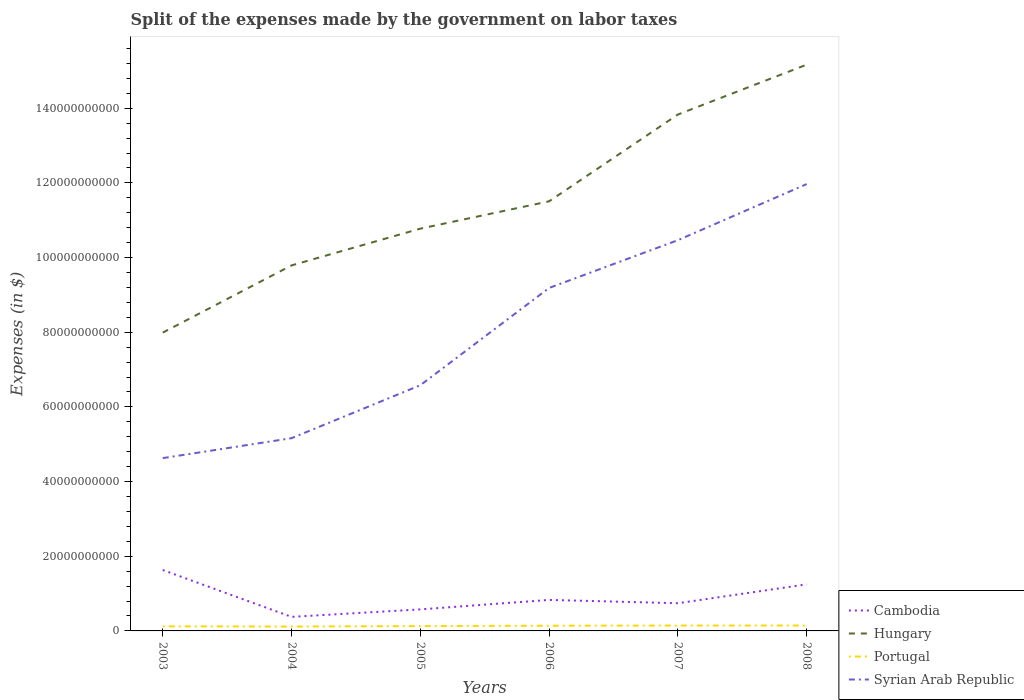Does the line corresponding to Cambodia intersect with the line corresponding to Syrian Arab Republic?
Provide a short and direct response. No. Across all years, what is the maximum expenses made by the government on labor taxes in Portugal?
Provide a succinct answer. 1.18e+09. What is the total expenses made by the government on labor taxes in Hungary in the graph?
Your response must be concise. -7.18e+1. What is the difference between the highest and the second highest expenses made by the government on labor taxes in Cambodia?
Offer a terse response. 1.26e+1. What is the difference between the highest and the lowest expenses made by the government on labor taxes in Hungary?
Keep it short and to the point. 2. Is the expenses made by the government on labor taxes in Hungary strictly greater than the expenses made by the government on labor taxes in Cambodia over the years?
Provide a short and direct response. No. How many years are there in the graph?
Ensure brevity in your answer.  6. Are the values on the major ticks of Y-axis written in scientific E-notation?
Your answer should be compact. No. Does the graph contain any zero values?
Make the answer very short. No. Does the graph contain grids?
Provide a short and direct response. No. How many legend labels are there?
Give a very brief answer. 4. How are the legend labels stacked?
Offer a terse response. Vertical. What is the title of the graph?
Offer a terse response. Split of the expenses made by the government on labor taxes. Does "Yemen, Rep." appear as one of the legend labels in the graph?
Give a very brief answer. No. What is the label or title of the X-axis?
Ensure brevity in your answer.  Years. What is the label or title of the Y-axis?
Make the answer very short. Expenses (in $). What is the Expenses (in $) of Cambodia in 2003?
Make the answer very short. 1.63e+1. What is the Expenses (in $) of Hungary in 2003?
Offer a very short reply. 7.99e+1. What is the Expenses (in $) in Portugal in 2003?
Your answer should be compact. 1.23e+09. What is the Expenses (in $) of Syrian Arab Republic in 2003?
Your response must be concise. 4.63e+1. What is the Expenses (in $) of Cambodia in 2004?
Give a very brief answer. 3.76e+09. What is the Expenses (in $) in Hungary in 2004?
Your answer should be compact. 9.79e+1. What is the Expenses (in $) of Portugal in 2004?
Ensure brevity in your answer.  1.18e+09. What is the Expenses (in $) in Syrian Arab Republic in 2004?
Provide a succinct answer. 5.16e+1. What is the Expenses (in $) of Cambodia in 2005?
Your response must be concise. 5.77e+09. What is the Expenses (in $) of Hungary in 2005?
Keep it short and to the point. 1.08e+11. What is the Expenses (in $) of Portugal in 2005?
Your response must be concise. 1.29e+09. What is the Expenses (in $) of Syrian Arab Republic in 2005?
Provide a short and direct response. 6.58e+1. What is the Expenses (in $) of Cambodia in 2006?
Your response must be concise. 8.30e+09. What is the Expenses (in $) in Hungary in 2006?
Your response must be concise. 1.15e+11. What is the Expenses (in $) of Portugal in 2006?
Make the answer very short. 1.39e+09. What is the Expenses (in $) in Syrian Arab Republic in 2006?
Ensure brevity in your answer.  9.19e+1. What is the Expenses (in $) of Cambodia in 2007?
Provide a succinct answer. 7.42e+09. What is the Expenses (in $) in Hungary in 2007?
Your answer should be compact. 1.38e+11. What is the Expenses (in $) of Portugal in 2007?
Your answer should be very brief. 1.44e+09. What is the Expenses (in $) in Syrian Arab Republic in 2007?
Your response must be concise. 1.05e+11. What is the Expenses (in $) in Cambodia in 2008?
Your answer should be very brief. 1.25e+1. What is the Expenses (in $) of Hungary in 2008?
Give a very brief answer. 1.52e+11. What is the Expenses (in $) of Portugal in 2008?
Your answer should be compact. 1.45e+09. What is the Expenses (in $) of Syrian Arab Republic in 2008?
Offer a very short reply. 1.20e+11. Across all years, what is the maximum Expenses (in $) in Cambodia?
Ensure brevity in your answer.  1.63e+1. Across all years, what is the maximum Expenses (in $) in Hungary?
Offer a terse response. 1.52e+11. Across all years, what is the maximum Expenses (in $) in Portugal?
Provide a short and direct response. 1.45e+09. Across all years, what is the maximum Expenses (in $) in Syrian Arab Republic?
Ensure brevity in your answer.  1.20e+11. Across all years, what is the minimum Expenses (in $) of Cambodia?
Your answer should be compact. 3.76e+09. Across all years, what is the minimum Expenses (in $) of Hungary?
Provide a succinct answer. 7.99e+1. Across all years, what is the minimum Expenses (in $) in Portugal?
Your response must be concise. 1.18e+09. Across all years, what is the minimum Expenses (in $) of Syrian Arab Republic?
Offer a very short reply. 4.63e+1. What is the total Expenses (in $) of Cambodia in the graph?
Make the answer very short. 5.40e+1. What is the total Expenses (in $) of Hungary in the graph?
Give a very brief answer. 6.91e+11. What is the total Expenses (in $) of Portugal in the graph?
Make the answer very short. 7.98e+09. What is the total Expenses (in $) in Syrian Arab Republic in the graph?
Ensure brevity in your answer.  4.80e+11. What is the difference between the Expenses (in $) in Cambodia in 2003 and that in 2004?
Give a very brief answer. 1.26e+1. What is the difference between the Expenses (in $) of Hungary in 2003 and that in 2004?
Make the answer very short. -1.80e+1. What is the difference between the Expenses (in $) of Portugal in 2003 and that in 2004?
Make the answer very short. 5.04e+07. What is the difference between the Expenses (in $) in Syrian Arab Republic in 2003 and that in 2004?
Offer a terse response. -5.34e+09. What is the difference between the Expenses (in $) of Cambodia in 2003 and that in 2005?
Offer a terse response. 1.05e+1. What is the difference between the Expenses (in $) of Hungary in 2003 and that in 2005?
Make the answer very short. -2.78e+1. What is the difference between the Expenses (in $) in Portugal in 2003 and that in 2005?
Offer a terse response. -6.48e+07. What is the difference between the Expenses (in $) in Syrian Arab Republic in 2003 and that in 2005?
Make the answer very short. -1.95e+1. What is the difference between the Expenses (in $) in Cambodia in 2003 and that in 2006?
Offer a very short reply. 8.01e+09. What is the difference between the Expenses (in $) in Hungary in 2003 and that in 2006?
Offer a terse response. -3.52e+1. What is the difference between the Expenses (in $) in Portugal in 2003 and that in 2006?
Provide a short and direct response. -1.65e+08. What is the difference between the Expenses (in $) of Syrian Arab Republic in 2003 and that in 2006?
Give a very brief answer. -4.56e+1. What is the difference between the Expenses (in $) of Cambodia in 2003 and that in 2007?
Your answer should be compact. 8.90e+09. What is the difference between the Expenses (in $) of Hungary in 2003 and that in 2007?
Your answer should be compact. -5.84e+1. What is the difference between the Expenses (in $) in Portugal in 2003 and that in 2007?
Offer a terse response. -2.08e+08. What is the difference between the Expenses (in $) in Syrian Arab Republic in 2003 and that in 2007?
Make the answer very short. -5.84e+1. What is the difference between the Expenses (in $) in Cambodia in 2003 and that in 2008?
Keep it short and to the point. 3.84e+09. What is the difference between the Expenses (in $) of Hungary in 2003 and that in 2008?
Provide a short and direct response. -7.18e+1. What is the difference between the Expenses (in $) of Portugal in 2003 and that in 2008?
Keep it short and to the point. -2.17e+08. What is the difference between the Expenses (in $) in Syrian Arab Republic in 2003 and that in 2008?
Give a very brief answer. -7.34e+1. What is the difference between the Expenses (in $) of Cambodia in 2004 and that in 2005?
Ensure brevity in your answer.  -2.01e+09. What is the difference between the Expenses (in $) in Hungary in 2004 and that in 2005?
Ensure brevity in your answer.  -9.84e+09. What is the difference between the Expenses (in $) in Portugal in 2004 and that in 2005?
Keep it short and to the point. -1.15e+08. What is the difference between the Expenses (in $) of Syrian Arab Republic in 2004 and that in 2005?
Provide a succinct answer. -1.42e+1. What is the difference between the Expenses (in $) in Cambodia in 2004 and that in 2006?
Offer a terse response. -4.54e+09. What is the difference between the Expenses (in $) of Hungary in 2004 and that in 2006?
Keep it short and to the point. -1.72e+1. What is the difference between the Expenses (in $) in Portugal in 2004 and that in 2006?
Offer a terse response. -2.15e+08. What is the difference between the Expenses (in $) in Syrian Arab Republic in 2004 and that in 2006?
Provide a short and direct response. -4.02e+1. What is the difference between the Expenses (in $) of Cambodia in 2004 and that in 2007?
Give a very brief answer. -3.66e+09. What is the difference between the Expenses (in $) in Hungary in 2004 and that in 2007?
Provide a succinct answer. -4.04e+1. What is the difference between the Expenses (in $) in Portugal in 2004 and that in 2007?
Give a very brief answer. -2.58e+08. What is the difference between the Expenses (in $) in Syrian Arab Republic in 2004 and that in 2007?
Your answer should be compact. -5.30e+1. What is the difference between the Expenses (in $) in Cambodia in 2004 and that in 2008?
Give a very brief answer. -8.72e+09. What is the difference between the Expenses (in $) in Hungary in 2004 and that in 2008?
Provide a succinct answer. -5.38e+1. What is the difference between the Expenses (in $) in Portugal in 2004 and that in 2008?
Your answer should be compact. -2.67e+08. What is the difference between the Expenses (in $) in Syrian Arab Republic in 2004 and that in 2008?
Provide a short and direct response. -6.81e+1. What is the difference between the Expenses (in $) in Cambodia in 2005 and that in 2006?
Your answer should be compact. -2.54e+09. What is the difference between the Expenses (in $) of Hungary in 2005 and that in 2006?
Provide a short and direct response. -7.32e+09. What is the difference between the Expenses (in $) in Portugal in 2005 and that in 2006?
Provide a succinct answer. -1.00e+08. What is the difference between the Expenses (in $) of Syrian Arab Republic in 2005 and that in 2006?
Provide a succinct answer. -2.61e+1. What is the difference between the Expenses (in $) of Cambodia in 2005 and that in 2007?
Make the answer very short. -1.65e+09. What is the difference between the Expenses (in $) in Hungary in 2005 and that in 2007?
Provide a short and direct response. -3.06e+1. What is the difference between the Expenses (in $) of Portugal in 2005 and that in 2007?
Your response must be concise. -1.43e+08. What is the difference between the Expenses (in $) in Syrian Arab Republic in 2005 and that in 2007?
Your answer should be compact. -3.89e+1. What is the difference between the Expenses (in $) of Cambodia in 2005 and that in 2008?
Your answer should be compact. -6.71e+09. What is the difference between the Expenses (in $) in Hungary in 2005 and that in 2008?
Offer a terse response. -4.39e+1. What is the difference between the Expenses (in $) of Portugal in 2005 and that in 2008?
Give a very brief answer. -1.52e+08. What is the difference between the Expenses (in $) of Syrian Arab Republic in 2005 and that in 2008?
Offer a very short reply. -5.39e+1. What is the difference between the Expenses (in $) in Cambodia in 2006 and that in 2007?
Your answer should be compact. 8.87e+08. What is the difference between the Expenses (in $) in Hungary in 2006 and that in 2007?
Your answer should be compact. -2.32e+1. What is the difference between the Expenses (in $) in Portugal in 2006 and that in 2007?
Your response must be concise. -4.29e+07. What is the difference between the Expenses (in $) of Syrian Arab Republic in 2006 and that in 2007?
Your answer should be very brief. -1.28e+1. What is the difference between the Expenses (in $) in Cambodia in 2006 and that in 2008?
Provide a short and direct response. -4.17e+09. What is the difference between the Expenses (in $) in Hungary in 2006 and that in 2008?
Ensure brevity in your answer.  -3.66e+1. What is the difference between the Expenses (in $) of Portugal in 2006 and that in 2008?
Give a very brief answer. -5.20e+07. What is the difference between the Expenses (in $) of Syrian Arab Republic in 2006 and that in 2008?
Make the answer very short. -2.78e+1. What is the difference between the Expenses (in $) in Cambodia in 2007 and that in 2008?
Offer a very short reply. -5.06e+09. What is the difference between the Expenses (in $) in Hungary in 2007 and that in 2008?
Provide a short and direct response. -1.34e+1. What is the difference between the Expenses (in $) of Portugal in 2007 and that in 2008?
Make the answer very short. -9.08e+06. What is the difference between the Expenses (in $) in Syrian Arab Republic in 2007 and that in 2008?
Give a very brief answer. -1.50e+1. What is the difference between the Expenses (in $) of Cambodia in 2003 and the Expenses (in $) of Hungary in 2004?
Your response must be concise. -8.16e+1. What is the difference between the Expenses (in $) in Cambodia in 2003 and the Expenses (in $) in Portugal in 2004?
Your answer should be very brief. 1.51e+1. What is the difference between the Expenses (in $) of Cambodia in 2003 and the Expenses (in $) of Syrian Arab Republic in 2004?
Keep it short and to the point. -3.53e+1. What is the difference between the Expenses (in $) of Hungary in 2003 and the Expenses (in $) of Portugal in 2004?
Ensure brevity in your answer.  7.87e+1. What is the difference between the Expenses (in $) in Hungary in 2003 and the Expenses (in $) in Syrian Arab Republic in 2004?
Provide a succinct answer. 2.83e+1. What is the difference between the Expenses (in $) in Portugal in 2003 and the Expenses (in $) in Syrian Arab Republic in 2004?
Offer a very short reply. -5.04e+1. What is the difference between the Expenses (in $) in Cambodia in 2003 and the Expenses (in $) in Hungary in 2005?
Offer a very short reply. -9.14e+1. What is the difference between the Expenses (in $) of Cambodia in 2003 and the Expenses (in $) of Portugal in 2005?
Offer a terse response. 1.50e+1. What is the difference between the Expenses (in $) in Cambodia in 2003 and the Expenses (in $) in Syrian Arab Republic in 2005?
Offer a terse response. -4.95e+1. What is the difference between the Expenses (in $) in Hungary in 2003 and the Expenses (in $) in Portugal in 2005?
Give a very brief answer. 7.86e+1. What is the difference between the Expenses (in $) in Hungary in 2003 and the Expenses (in $) in Syrian Arab Republic in 2005?
Your answer should be very brief. 1.41e+1. What is the difference between the Expenses (in $) in Portugal in 2003 and the Expenses (in $) in Syrian Arab Republic in 2005?
Offer a terse response. -6.46e+1. What is the difference between the Expenses (in $) of Cambodia in 2003 and the Expenses (in $) of Hungary in 2006?
Make the answer very short. -9.88e+1. What is the difference between the Expenses (in $) of Cambodia in 2003 and the Expenses (in $) of Portugal in 2006?
Ensure brevity in your answer.  1.49e+1. What is the difference between the Expenses (in $) in Cambodia in 2003 and the Expenses (in $) in Syrian Arab Republic in 2006?
Provide a short and direct response. -7.56e+1. What is the difference between the Expenses (in $) of Hungary in 2003 and the Expenses (in $) of Portugal in 2006?
Provide a succinct answer. 7.85e+1. What is the difference between the Expenses (in $) in Hungary in 2003 and the Expenses (in $) in Syrian Arab Republic in 2006?
Provide a short and direct response. -1.20e+1. What is the difference between the Expenses (in $) of Portugal in 2003 and the Expenses (in $) of Syrian Arab Republic in 2006?
Provide a succinct answer. -9.06e+1. What is the difference between the Expenses (in $) of Cambodia in 2003 and the Expenses (in $) of Hungary in 2007?
Make the answer very short. -1.22e+11. What is the difference between the Expenses (in $) in Cambodia in 2003 and the Expenses (in $) in Portugal in 2007?
Provide a short and direct response. 1.49e+1. What is the difference between the Expenses (in $) in Cambodia in 2003 and the Expenses (in $) in Syrian Arab Republic in 2007?
Provide a short and direct response. -8.83e+1. What is the difference between the Expenses (in $) of Hungary in 2003 and the Expenses (in $) of Portugal in 2007?
Make the answer very short. 7.85e+1. What is the difference between the Expenses (in $) of Hungary in 2003 and the Expenses (in $) of Syrian Arab Republic in 2007?
Provide a short and direct response. -2.48e+1. What is the difference between the Expenses (in $) of Portugal in 2003 and the Expenses (in $) of Syrian Arab Republic in 2007?
Offer a terse response. -1.03e+11. What is the difference between the Expenses (in $) of Cambodia in 2003 and the Expenses (in $) of Hungary in 2008?
Your answer should be very brief. -1.35e+11. What is the difference between the Expenses (in $) in Cambodia in 2003 and the Expenses (in $) in Portugal in 2008?
Keep it short and to the point. 1.49e+1. What is the difference between the Expenses (in $) of Cambodia in 2003 and the Expenses (in $) of Syrian Arab Republic in 2008?
Provide a short and direct response. -1.03e+11. What is the difference between the Expenses (in $) of Hungary in 2003 and the Expenses (in $) of Portugal in 2008?
Provide a short and direct response. 7.85e+1. What is the difference between the Expenses (in $) of Hungary in 2003 and the Expenses (in $) of Syrian Arab Republic in 2008?
Make the answer very short. -3.98e+1. What is the difference between the Expenses (in $) in Portugal in 2003 and the Expenses (in $) in Syrian Arab Republic in 2008?
Make the answer very short. -1.18e+11. What is the difference between the Expenses (in $) of Cambodia in 2004 and the Expenses (in $) of Hungary in 2005?
Make the answer very short. -1.04e+11. What is the difference between the Expenses (in $) of Cambodia in 2004 and the Expenses (in $) of Portugal in 2005?
Keep it short and to the point. 2.47e+09. What is the difference between the Expenses (in $) in Cambodia in 2004 and the Expenses (in $) in Syrian Arab Republic in 2005?
Offer a terse response. -6.20e+1. What is the difference between the Expenses (in $) in Hungary in 2004 and the Expenses (in $) in Portugal in 2005?
Keep it short and to the point. 9.66e+1. What is the difference between the Expenses (in $) in Hungary in 2004 and the Expenses (in $) in Syrian Arab Republic in 2005?
Provide a succinct answer. 3.21e+1. What is the difference between the Expenses (in $) in Portugal in 2004 and the Expenses (in $) in Syrian Arab Republic in 2005?
Your response must be concise. -6.46e+1. What is the difference between the Expenses (in $) in Cambodia in 2004 and the Expenses (in $) in Hungary in 2006?
Your response must be concise. -1.11e+11. What is the difference between the Expenses (in $) in Cambodia in 2004 and the Expenses (in $) in Portugal in 2006?
Keep it short and to the point. 2.37e+09. What is the difference between the Expenses (in $) in Cambodia in 2004 and the Expenses (in $) in Syrian Arab Republic in 2006?
Ensure brevity in your answer.  -8.81e+1. What is the difference between the Expenses (in $) in Hungary in 2004 and the Expenses (in $) in Portugal in 2006?
Give a very brief answer. 9.65e+1. What is the difference between the Expenses (in $) of Hungary in 2004 and the Expenses (in $) of Syrian Arab Republic in 2006?
Give a very brief answer. 6.04e+09. What is the difference between the Expenses (in $) of Portugal in 2004 and the Expenses (in $) of Syrian Arab Republic in 2006?
Offer a terse response. -9.07e+1. What is the difference between the Expenses (in $) of Cambodia in 2004 and the Expenses (in $) of Hungary in 2007?
Your response must be concise. -1.35e+11. What is the difference between the Expenses (in $) of Cambodia in 2004 and the Expenses (in $) of Portugal in 2007?
Keep it short and to the point. 2.33e+09. What is the difference between the Expenses (in $) in Cambodia in 2004 and the Expenses (in $) in Syrian Arab Republic in 2007?
Ensure brevity in your answer.  -1.01e+11. What is the difference between the Expenses (in $) of Hungary in 2004 and the Expenses (in $) of Portugal in 2007?
Ensure brevity in your answer.  9.65e+1. What is the difference between the Expenses (in $) of Hungary in 2004 and the Expenses (in $) of Syrian Arab Republic in 2007?
Provide a short and direct response. -6.76e+09. What is the difference between the Expenses (in $) of Portugal in 2004 and the Expenses (in $) of Syrian Arab Republic in 2007?
Your answer should be very brief. -1.03e+11. What is the difference between the Expenses (in $) in Cambodia in 2004 and the Expenses (in $) in Hungary in 2008?
Provide a short and direct response. -1.48e+11. What is the difference between the Expenses (in $) in Cambodia in 2004 and the Expenses (in $) in Portugal in 2008?
Your response must be concise. 2.32e+09. What is the difference between the Expenses (in $) of Cambodia in 2004 and the Expenses (in $) of Syrian Arab Republic in 2008?
Keep it short and to the point. -1.16e+11. What is the difference between the Expenses (in $) of Hungary in 2004 and the Expenses (in $) of Portugal in 2008?
Your answer should be compact. 9.65e+1. What is the difference between the Expenses (in $) in Hungary in 2004 and the Expenses (in $) in Syrian Arab Republic in 2008?
Give a very brief answer. -2.18e+1. What is the difference between the Expenses (in $) of Portugal in 2004 and the Expenses (in $) of Syrian Arab Republic in 2008?
Provide a succinct answer. -1.19e+11. What is the difference between the Expenses (in $) of Cambodia in 2005 and the Expenses (in $) of Hungary in 2006?
Your response must be concise. -1.09e+11. What is the difference between the Expenses (in $) of Cambodia in 2005 and the Expenses (in $) of Portugal in 2006?
Ensure brevity in your answer.  4.37e+09. What is the difference between the Expenses (in $) of Cambodia in 2005 and the Expenses (in $) of Syrian Arab Republic in 2006?
Provide a succinct answer. -8.61e+1. What is the difference between the Expenses (in $) of Hungary in 2005 and the Expenses (in $) of Portugal in 2006?
Ensure brevity in your answer.  1.06e+11. What is the difference between the Expenses (in $) of Hungary in 2005 and the Expenses (in $) of Syrian Arab Republic in 2006?
Provide a short and direct response. 1.59e+1. What is the difference between the Expenses (in $) of Portugal in 2005 and the Expenses (in $) of Syrian Arab Republic in 2006?
Ensure brevity in your answer.  -9.06e+1. What is the difference between the Expenses (in $) of Cambodia in 2005 and the Expenses (in $) of Hungary in 2007?
Your answer should be compact. -1.33e+11. What is the difference between the Expenses (in $) of Cambodia in 2005 and the Expenses (in $) of Portugal in 2007?
Your answer should be compact. 4.33e+09. What is the difference between the Expenses (in $) of Cambodia in 2005 and the Expenses (in $) of Syrian Arab Republic in 2007?
Provide a short and direct response. -9.89e+1. What is the difference between the Expenses (in $) of Hungary in 2005 and the Expenses (in $) of Portugal in 2007?
Your response must be concise. 1.06e+11. What is the difference between the Expenses (in $) of Hungary in 2005 and the Expenses (in $) of Syrian Arab Republic in 2007?
Your response must be concise. 3.09e+09. What is the difference between the Expenses (in $) of Portugal in 2005 and the Expenses (in $) of Syrian Arab Republic in 2007?
Your answer should be compact. -1.03e+11. What is the difference between the Expenses (in $) of Cambodia in 2005 and the Expenses (in $) of Hungary in 2008?
Offer a terse response. -1.46e+11. What is the difference between the Expenses (in $) of Cambodia in 2005 and the Expenses (in $) of Portugal in 2008?
Your response must be concise. 4.32e+09. What is the difference between the Expenses (in $) in Cambodia in 2005 and the Expenses (in $) in Syrian Arab Republic in 2008?
Provide a succinct answer. -1.14e+11. What is the difference between the Expenses (in $) of Hungary in 2005 and the Expenses (in $) of Portugal in 2008?
Make the answer very short. 1.06e+11. What is the difference between the Expenses (in $) in Hungary in 2005 and the Expenses (in $) in Syrian Arab Republic in 2008?
Make the answer very short. -1.19e+1. What is the difference between the Expenses (in $) of Portugal in 2005 and the Expenses (in $) of Syrian Arab Republic in 2008?
Provide a short and direct response. -1.18e+11. What is the difference between the Expenses (in $) in Cambodia in 2006 and the Expenses (in $) in Hungary in 2007?
Your answer should be compact. -1.30e+11. What is the difference between the Expenses (in $) in Cambodia in 2006 and the Expenses (in $) in Portugal in 2007?
Your answer should be very brief. 6.87e+09. What is the difference between the Expenses (in $) of Cambodia in 2006 and the Expenses (in $) of Syrian Arab Republic in 2007?
Ensure brevity in your answer.  -9.64e+1. What is the difference between the Expenses (in $) of Hungary in 2006 and the Expenses (in $) of Portugal in 2007?
Give a very brief answer. 1.14e+11. What is the difference between the Expenses (in $) of Hungary in 2006 and the Expenses (in $) of Syrian Arab Republic in 2007?
Give a very brief answer. 1.04e+1. What is the difference between the Expenses (in $) in Portugal in 2006 and the Expenses (in $) in Syrian Arab Republic in 2007?
Your response must be concise. -1.03e+11. What is the difference between the Expenses (in $) of Cambodia in 2006 and the Expenses (in $) of Hungary in 2008?
Your response must be concise. -1.43e+11. What is the difference between the Expenses (in $) in Cambodia in 2006 and the Expenses (in $) in Portugal in 2008?
Provide a succinct answer. 6.86e+09. What is the difference between the Expenses (in $) of Cambodia in 2006 and the Expenses (in $) of Syrian Arab Republic in 2008?
Ensure brevity in your answer.  -1.11e+11. What is the difference between the Expenses (in $) in Hungary in 2006 and the Expenses (in $) in Portugal in 2008?
Give a very brief answer. 1.14e+11. What is the difference between the Expenses (in $) of Hungary in 2006 and the Expenses (in $) of Syrian Arab Republic in 2008?
Offer a terse response. -4.62e+09. What is the difference between the Expenses (in $) in Portugal in 2006 and the Expenses (in $) in Syrian Arab Republic in 2008?
Your response must be concise. -1.18e+11. What is the difference between the Expenses (in $) in Cambodia in 2007 and the Expenses (in $) in Hungary in 2008?
Your response must be concise. -1.44e+11. What is the difference between the Expenses (in $) of Cambodia in 2007 and the Expenses (in $) of Portugal in 2008?
Keep it short and to the point. 5.97e+09. What is the difference between the Expenses (in $) of Cambodia in 2007 and the Expenses (in $) of Syrian Arab Republic in 2008?
Provide a short and direct response. -1.12e+11. What is the difference between the Expenses (in $) in Hungary in 2007 and the Expenses (in $) in Portugal in 2008?
Your response must be concise. 1.37e+11. What is the difference between the Expenses (in $) in Hungary in 2007 and the Expenses (in $) in Syrian Arab Republic in 2008?
Provide a short and direct response. 1.86e+1. What is the difference between the Expenses (in $) of Portugal in 2007 and the Expenses (in $) of Syrian Arab Republic in 2008?
Offer a terse response. -1.18e+11. What is the average Expenses (in $) of Cambodia per year?
Give a very brief answer. 9.01e+09. What is the average Expenses (in $) of Hungary per year?
Provide a succinct answer. 1.15e+11. What is the average Expenses (in $) of Portugal per year?
Offer a terse response. 1.33e+09. What is the average Expenses (in $) of Syrian Arab Republic per year?
Your response must be concise. 8.00e+1. In the year 2003, what is the difference between the Expenses (in $) of Cambodia and Expenses (in $) of Hungary?
Provide a succinct answer. -6.36e+1. In the year 2003, what is the difference between the Expenses (in $) of Cambodia and Expenses (in $) of Portugal?
Offer a very short reply. 1.51e+1. In the year 2003, what is the difference between the Expenses (in $) of Cambodia and Expenses (in $) of Syrian Arab Republic?
Give a very brief answer. -3.00e+1. In the year 2003, what is the difference between the Expenses (in $) in Hungary and Expenses (in $) in Portugal?
Ensure brevity in your answer.  7.87e+1. In the year 2003, what is the difference between the Expenses (in $) of Hungary and Expenses (in $) of Syrian Arab Republic?
Your response must be concise. 3.36e+1. In the year 2003, what is the difference between the Expenses (in $) of Portugal and Expenses (in $) of Syrian Arab Republic?
Provide a succinct answer. -4.51e+1. In the year 2004, what is the difference between the Expenses (in $) in Cambodia and Expenses (in $) in Hungary?
Make the answer very short. -9.41e+1. In the year 2004, what is the difference between the Expenses (in $) of Cambodia and Expenses (in $) of Portugal?
Your answer should be very brief. 2.58e+09. In the year 2004, what is the difference between the Expenses (in $) of Cambodia and Expenses (in $) of Syrian Arab Republic?
Provide a succinct answer. -4.79e+1. In the year 2004, what is the difference between the Expenses (in $) in Hungary and Expenses (in $) in Portugal?
Your answer should be very brief. 9.67e+1. In the year 2004, what is the difference between the Expenses (in $) of Hungary and Expenses (in $) of Syrian Arab Republic?
Give a very brief answer. 4.63e+1. In the year 2004, what is the difference between the Expenses (in $) in Portugal and Expenses (in $) in Syrian Arab Republic?
Ensure brevity in your answer.  -5.04e+1. In the year 2005, what is the difference between the Expenses (in $) of Cambodia and Expenses (in $) of Hungary?
Your response must be concise. -1.02e+11. In the year 2005, what is the difference between the Expenses (in $) of Cambodia and Expenses (in $) of Portugal?
Provide a succinct answer. 4.47e+09. In the year 2005, what is the difference between the Expenses (in $) in Cambodia and Expenses (in $) in Syrian Arab Republic?
Provide a succinct answer. -6.00e+1. In the year 2005, what is the difference between the Expenses (in $) of Hungary and Expenses (in $) of Portugal?
Make the answer very short. 1.06e+11. In the year 2005, what is the difference between the Expenses (in $) of Hungary and Expenses (in $) of Syrian Arab Republic?
Provide a succinct answer. 4.19e+1. In the year 2005, what is the difference between the Expenses (in $) in Portugal and Expenses (in $) in Syrian Arab Republic?
Offer a terse response. -6.45e+1. In the year 2006, what is the difference between the Expenses (in $) of Cambodia and Expenses (in $) of Hungary?
Your answer should be very brief. -1.07e+11. In the year 2006, what is the difference between the Expenses (in $) of Cambodia and Expenses (in $) of Portugal?
Your answer should be compact. 6.91e+09. In the year 2006, what is the difference between the Expenses (in $) of Cambodia and Expenses (in $) of Syrian Arab Republic?
Offer a terse response. -8.36e+1. In the year 2006, what is the difference between the Expenses (in $) of Hungary and Expenses (in $) of Portugal?
Provide a succinct answer. 1.14e+11. In the year 2006, what is the difference between the Expenses (in $) in Hungary and Expenses (in $) in Syrian Arab Republic?
Your answer should be compact. 2.32e+1. In the year 2006, what is the difference between the Expenses (in $) in Portugal and Expenses (in $) in Syrian Arab Republic?
Ensure brevity in your answer.  -9.05e+1. In the year 2007, what is the difference between the Expenses (in $) of Cambodia and Expenses (in $) of Hungary?
Provide a succinct answer. -1.31e+11. In the year 2007, what is the difference between the Expenses (in $) in Cambodia and Expenses (in $) in Portugal?
Provide a succinct answer. 5.98e+09. In the year 2007, what is the difference between the Expenses (in $) in Cambodia and Expenses (in $) in Syrian Arab Republic?
Offer a terse response. -9.72e+1. In the year 2007, what is the difference between the Expenses (in $) in Hungary and Expenses (in $) in Portugal?
Make the answer very short. 1.37e+11. In the year 2007, what is the difference between the Expenses (in $) in Hungary and Expenses (in $) in Syrian Arab Republic?
Keep it short and to the point. 3.37e+1. In the year 2007, what is the difference between the Expenses (in $) in Portugal and Expenses (in $) in Syrian Arab Republic?
Provide a succinct answer. -1.03e+11. In the year 2008, what is the difference between the Expenses (in $) in Cambodia and Expenses (in $) in Hungary?
Your response must be concise. -1.39e+11. In the year 2008, what is the difference between the Expenses (in $) in Cambodia and Expenses (in $) in Portugal?
Offer a very short reply. 1.10e+1. In the year 2008, what is the difference between the Expenses (in $) of Cambodia and Expenses (in $) of Syrian Arab Republic?
Provide a succinct answer. -1.07e+11. In the year 2008, what is the difference between the Expenses (in $) in Hungary and Expenses (in $) in Portugal?
Your answer should be compact. 1.50e+11. In the year 2008, what is the difference between the Expenses (in $) in Hungary and Expenses (in $) in Syrian Arab Republic?
Keep it short and to the point. 3.20e+1. In the year 2008, what is the difference between the Expenses (in $) in Portugal and Expenses (in $) in Syrian Arab Republic?
Your answer should be very brief. -1.18e+11. What is the ratio of the Expenses (in $) in Cambodia in 2003 to that in 2004?
Your answer should be compact. 4.34. What is the ratio of the Expenses (in $) in Hungary in 2003 to that in 2004?
Keep it short and to the point. 0.82. What is the ratio of the Expenses (in $) of Portugal in 2003 to that in 2004?
Give a very brief answer. 1.04. What is the ratio of the Expenses (in $) in Syrian Arab Republic in 2003 to that in 2004?
Keep it short and to the point. 0.9. What is the ratio of the Expenses (in $) of Cambodia in 2003 to that in 2005?
Make the answer very short. 2.83. What is the ratio of the Expenses (in $) of Hungary in 2003 to that in 2005?
Your answer should be very brief. 0.74. What is the ratio of the Expenses (in $) of Portugal in 2003 to that in 2005?
Offer a very short reply. 0.95. What is the ratio of the Expenses (in $) in Syrian Arab Republic in 2003 to that in 2005?
Offer a very short reply. 0.7. What is the ratio of the Expenses (in $) in Cambodia in 2003 to that in 2006?
Ensure brevity in your answer.  1.96. What is the ratio of the Expenses (in $) in Hungary in 2003 to that in 2006?
Make the answer very short. 0.69. What is the ratio of the Expenses (in $) of Portugal in 2003 to that in 2006?
Your response must be concise. 0.88. What is the ratio of the Expenses (in $) in Syrian Arab Republic in 2003 to that in 2006?
Offer a very short reply. 0.5. What is the ratio of the Expenses (in $) in Cambodia in 2003 to that in 2007?
Give a very brief answer. 2.2. What is the ratio of the Expenses (in $) of Hungary in 2003 to that in 2007?
Your answer should be compact. 0.58. What is the ratio of the Expenses (in $) in Portugal in 2003 to that in 2007?
Your response must be concise. 0.86. What is the ratio of the Expenses (in $) in Syrian Arab Republic in 2003 to that in 2007?
Provide a succinct answer. 0.44. What is the ratio of the Expenses (in $) of Cambodia in 2003 to that in 2008?
Offer a terse response. 1.31. What is the ratio of the Expenses (in $) of Hungary in 2003 to that in 2008?
Your response must be concise. 0.53. What is the ratio of the Expenses (in $) of Syrian Arab Republic in 2003 to that in 2008?
Make the answer very short. 0.39. What is the ratio of the Expenses (in $) of Cambodia in 2004 to that in 2005?
Ensure brevity in your answer.  0.65. What is the ratio of the Expenses (in $) of Hungary in 2004 to that in 2005?
Provide a short and direct response. 0.91. What is the ratio of the Expenses (in $) of Portugal in 2004 to that in 2005?
Make the answer very short. 0.91. What is the ratio of the Expenses (in $) of Syrian Arab Republic in 2004 to that in 2005?
Give a very brief answer. 0.78. What is the ratio of the Expenses (in $) in Cambodia in 2004 to that in 2006?
Your answer should be compact. 0.45. What is the ratio of the Expenses (in $) in Hungary in 2004 to that in 2006?
Make the answer very short. 0.85. What is the ratio of the Expenses (in $) of Portugal in 2004 to that in 2006?
Ensure brevity in your answer.  0.85. What is the ratio of the Expenses (in $) of Syrian Arab Republic in 2004 to that in 2006?
Your response must be concise. 0.56. What is the ratio of the Expenses (in $) in Cambodia in 2004 to that in 2007?
Your response must be concise. 0.51. What is the ratio of the Expenses (in $) in Hungary in 2004 to that in 2007?
Provide a short and direct response. 0.71. What is the ratio of the Expenses (in $) in Portugal in 2004 to that in 2007?
Provide a short and direct response. 0.82. What is the ratio of the Expenses (in $) of Syrian Arab Republic in 2004 to that in 2007?
Your answer should be compact. 0.49. What is the ratio of the Expenses (in $) in Cambodia in 2004 to that in 2008?
Provide a succinct answer. 0.3. What is the ratio of the Expenses (in $) of Hungary in 2004 to that in 2008?
Give a very brief answer. 0.65. What is the ratio of the Expenses (in $) in Portugal in 2004 to that in 2008?
Make the answer very short. 0.82. What is the ratio of the Expenses (in $) of Syrian Arab Republic in 2004 to that in 2008?
Make the answer very short. 0.43. What is the ratio of the Expenses (in $) of Cambodia in 2005 to that in 2006?
Offer a very short reply. 0.69. What is the ratio of the Expenses (in $) of Hungary in 2005 to that in 2006?
Offer a very short reply. 0.94. What is the ratio of the Expenses (in $) in Portugal in 2005 to that in 2006?
Keep it short and to the point. 0.93. What is the ratio of the Expenses (in $) in Syrian Arab Republic in 2005 to that in 2006?
Make the answer very short. 0.72. What is the ratio of the Expenses (in $) in Cambodia in 2005 to that in 2007?
Offer a terse response. 0.78. What is the ratio of the Expenses (in $) in Hungary in 2005 to that in 2007?
Your answer should be very brief. 0.78. What is the ratio of the Expenses (in $) of Portugal in 2005 to that in 2007?
Give a very brief answer. 0.9. What is the ratio of the Expenses (in $) of Syrian Arab Republic in 2005 to that in 2007?
Make the answer very short. 0.63. What is the ratio of the Expenses (in $) of Cambodia in 2005 to that in 2008?
Give a very brief answer. 0.46. What is the ratio of the Expenses (in $) in Hungary in 2005 to that in 2008?
Your response must be concise. 0.71. What is the ratio of the Expenses (in $) in Portugal in 2005 to that in 2008?
Provide a short and direct response. 0.89. What is the ratio of the Expenses (in $) of Syrian Arab Republic in 2005 to that in 2008?
Your response must be concise. 0.55. What is the ratio of the Expenses (in $) of Cambodia in 2006 to that in 2007?
Offer a very short reply. 1.12. What is the ratio of the Expenses (in $) of Hungary in 2006 to that in 2007?
Offer a terse response. 0.83. What is the ratio of the Expenses (in $) in Portugal in 2006 to that in 2007?
Ensure brevity in your answer.  0.97. What is the ratio of the Expenses (in $) in Syrian Arab Republic in 2006 to that in 2007?
Provide a succinct answer. 0.88. What is the ratio of the Expenses (in $) in Cambodia in 2006 to that in 2008?
Offer a very short reply. 0.67. What is the ratio of the Expenses (in $) in Hungary in 2006 to that in 2008?
Make the answer very short. 0.76. What is the ratio of the Expenses (in $) in Syrian Arab Republic in 2006 to that in 2008?
Ensure brevity in your answer.  0.77. What is the ratio of the Expenses (in $) of Cambodia in 2007 to that in 2008?
Your answer should be very brief. 0.59. What is the ratio of the Expenses (in $) of Hungary in 2007 to that in 2008?
Offer a terse response. 0.91. What is the ratio of the Expenses (in $) in Syrian Arab Republic in 2007 to that in 2008?
Provide a succinct answer. 0.87. What is the difference between the highest and the second highest Expenses (in $) of Cambodia?
Give a very brief answer. 3.84e+09. What is the difference between the highest and the second highest Expenses (in $) in Hungary?
Your answer should be very brief. 1.34e+1. What is the difference between the highest and the second highest Expenses (in $) in Portugal?
Provide a succinct answer. 9.08e+06. What is the difference between the highest and the second highest Expenses (in $) in Syrian Arab Republic?
Offer a terse response. 1.50e+1. What is the difference between the highest and the lowest Expenses (in $) of Cambodia?
Provide a succinct answer. 1.26e+1. What is the difference between the highest and the lowest Expenses (in $) in Hungary?
Provide a succinct answer. 7.18e+1. What is the difference between the highest and the lowest Expenses (in $) in Portugal?
Your answer should be compact. 2.67e+08. What is the difference between the highest and the lowest Expenses (in $) of Syrian Arab Republic?
Provide a succinct answer. 7.34e+1. 